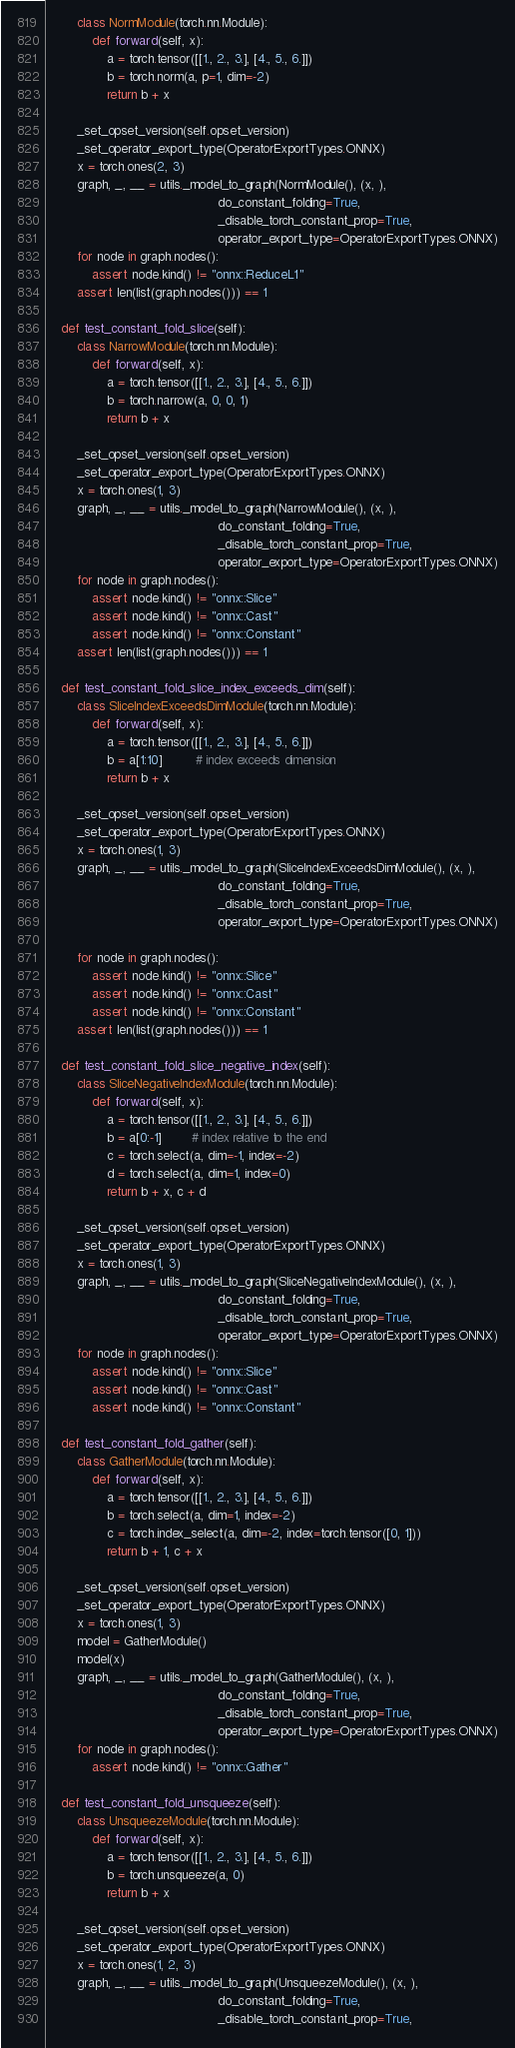<code> <loc_0><loc_0><loc_500><loc_500><_Python_>        class NormModule(torch.nn.Module):
            def forward(self, x):
                a = torch.tensor([[1., 2., 3.], [4., 5., 6.]])
                b = torch.norm(a, p=1, dim=-2)
                return b + x

        _set_opset_version(self.opset_version)
        _set_operator_export_type(OperatorExportTypes.ONNX)
        x = torch.ones(2, 3)
        graph, _, __ = utils._model_to_graph(NormModule(), (x, ),
                                             do_constant_folding=True,
                                             _disable_torch_constant_prop=True,
                                             operator_export_type=OperatorExportTypes.ONNX)
        for node in graph.nodes():
            assert node.kind() != "onnx::ReduceL1"
        assert len(list(graph.nodes())) == 1

    def test_constant_fold_slice(self):
        class NarrowModule(torch.nn.Module):
            def forward(self, x):
                a = torch.tensor([[1., 2., 3.], [4., 5., 6.]])
                b = torch.narrow(a, 0, 0, 1)
                return b + x

        _set_opset_version(self.opset_version)
        _set_operator_export_type(OperatorExportTypes.ONNX)
        x = torch.ones(1, 3)
        graph, _, __ = utils._model_to_graph(NarrowModule(), (x, ),
                                             do_constant_folding=True,
                                             _disable_torch_constant_prop=True,
                                             operator_export_type=OperatorExportTypes.ONNX)
        for node in graph.nodes():
            assert node.kind() != "onnx::Slice"
            assert node.kind() != "onnx::Cast"
            assert node.kind() != "onnx::Constant"
        assert len(list(graph.nodes())) == 1

    def test_constant_fold_slice_index_exceeds_dim(self):
        class SliceIndexExceedsDimModule(torch.nn.Module):
            def forward(self, x):
                a = torch.tensor([[1., 2., 3.], [4., 5., 6.]])
                b = a[1:10]         # index exceeds dimension
                return b + x

        _set_opset_version(self.opset_version)
        _set_operator_export_type(OperatorExportTypes.ONNX)
        x = torch.ones(1, 3)
        graph, _, __ = utils._model_to_graph(SliceIndexExceedsDimModule(), (x, ),
                                             do_constant_folding=True,
                                             _disable_torch_constant_prop=True,
                                             operator_export_type=OperatorExportTypes.ONNX)

        for node in graph.nodes():
            assert node.kind() != "onnx::Slice"
            assert node.kind() != "onnx::Cast"
            assert node.kind() != "onnx::Constant"
        assert len(list(graph.nodes())) == 1

    def test_constant_fold_slice_negative_index(self):
        class SliceNegativeIndexModule(torch.nn.Module):
            def forward(self, x):
                a = torch.tensor([[1., 2., 3.], [4., 5., 6.]])
                b = a[0:-1]        # index relative to the end
                c = torch.select(a, dim=-1, index=-2)
                d = torch.select(a, dim=1, index=0)
                return b + x, c + d

        _set_opset_version(self.opset_version)
        _set_operator_export_type(OperatorExportTypes.ONNX)
        x = torch.ones(1, 3)
        graph, _, __ = utils._model_to_graph(SliceNegativeIndexModule(), (x, ),
                                             do_constant_folding=True,
                                             _disable_torch_constant_prop=True,
                                             operator_export_type=OperatorExportTypes.ONNX)
        for node in graph.nodes():
            assert node.kind() != "onnx::Slice"
            assert node.kind() != "onnx::Cast"
            assert node.kind() != "onnx::Constant"

    def test_constant_fold_gather(self):
        class GatherModule(torch.nn.Module):
            def forward(self, x):
                a = torch.tensor([[1., 2., 3.], [4., 5., 6.]])
                b = torch.select(a, dim=1, index=-2)
                c = torch.index_select(a, dim=-2, index=torch.tensor([0, 1]))
                return b + 1, c + x

        _set_opset_version(self.opset_version)
        _set_operator_export_type(OperatorExportTypes.ONNX)
        x = torch.ones(1, 3)
        model = GatherModule()
        model(x)
        graph, _, __ = utils._model_to_graph(GatherModule(), (x, ),
                                             do_constant_folding=True,
                                             _disable_torch_constant_prop=True,
                                             operator_export_type=OperatorExportTypes.ONNX)
        for node in graph.nodes():
            assert node.kind() != "onnx::Gather"

    def test_constant_fold_unsqueeze(self):
        class UnsqueezeModule(torch.nn.Module):
            def forward(self, x):
                a = torch.tensor([[1., 2., 3.], [4., 5., 6.]])
                b = torch.unsqueeze(a, 0)
                return b + x

        _set_opset_version(self.opset_version)
        _set_operator_export_type(OperatorExportTypes.ONNX)
        x = torch.ones(1, 2, 3)
        graph, _, __ = utils._model_to_graph(UnsqueezeModule(), (x, ),
                                             do_constant_folding=True,
                                             _disable_torch_constant_prop=True,</code> 